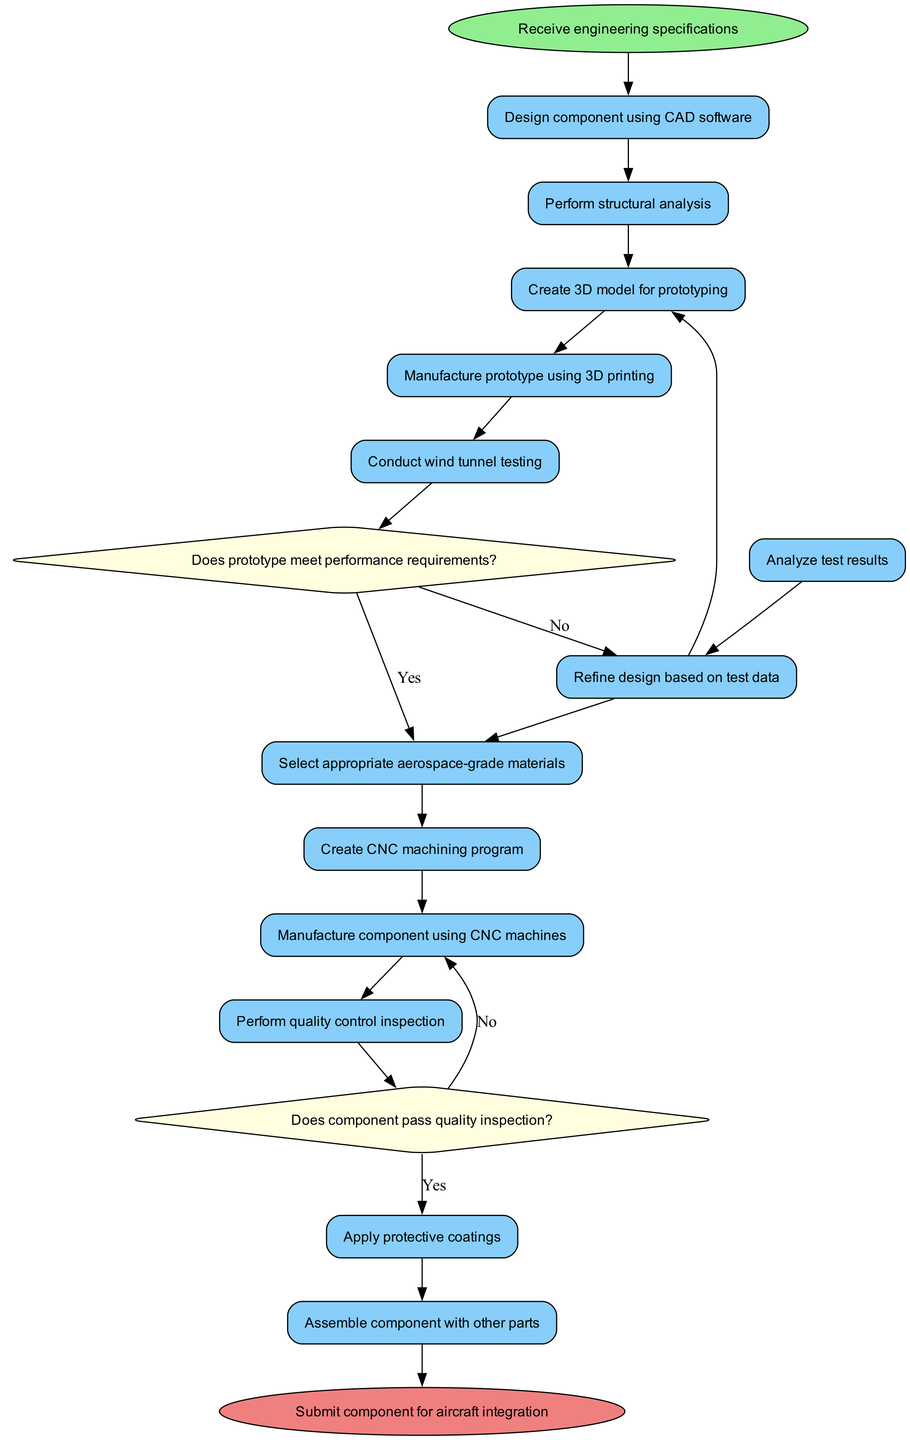What is the initial node in the diagram? The initial node is the starting point of the process, labeled "Receive engineering specifications."
Answer: Receive engineering specifications How many activities are there in the diagram? The diagram lists 13 distinct activities that represent steps in the manufacturing process.
Answer: 13 What condition leads to selecting materials in the diagram? The decision node for selecting materials is reached after testing the prototype for performance requirements; if it meets these, materials are selected.
Answer: Does prototype meet performance requirements? What happens if the component does not pass quality inspection? If the component fails quality inspection, the flow goes back to "Manufacture component using CNC machines" to ensure quality before proceeding.
Answer: Manufacture component using CNC machines What is the final node of the diagram? The final node marks the end of the process and is labeled "Submit component for aircraft integration," representing the completion of the manufacturing workflow.
Answer: Submit component for aircraft integration What is the activity before conducting wind tunnel testing? Prior to conducting wind tunnel testing, the activity that occurs is "Manufacture prototype using 3D printing," which involves creating the model for testing.
Answer: Manufacture prototype using 3D printing How many decision nodes are present in the diagram? The diagram contains 2 decision nodes, each followed by the respective conditions and subsequent actions based on the outcomes.
Answer: 2 What is the decision made after conducting wind tunnel testing? After conducting wind tunnel testing, a decision must be made based on whether the prototype meets performance requirements, which leads to selecting materials or refining the design.
Answer: Does prototype meet performance requirements? 